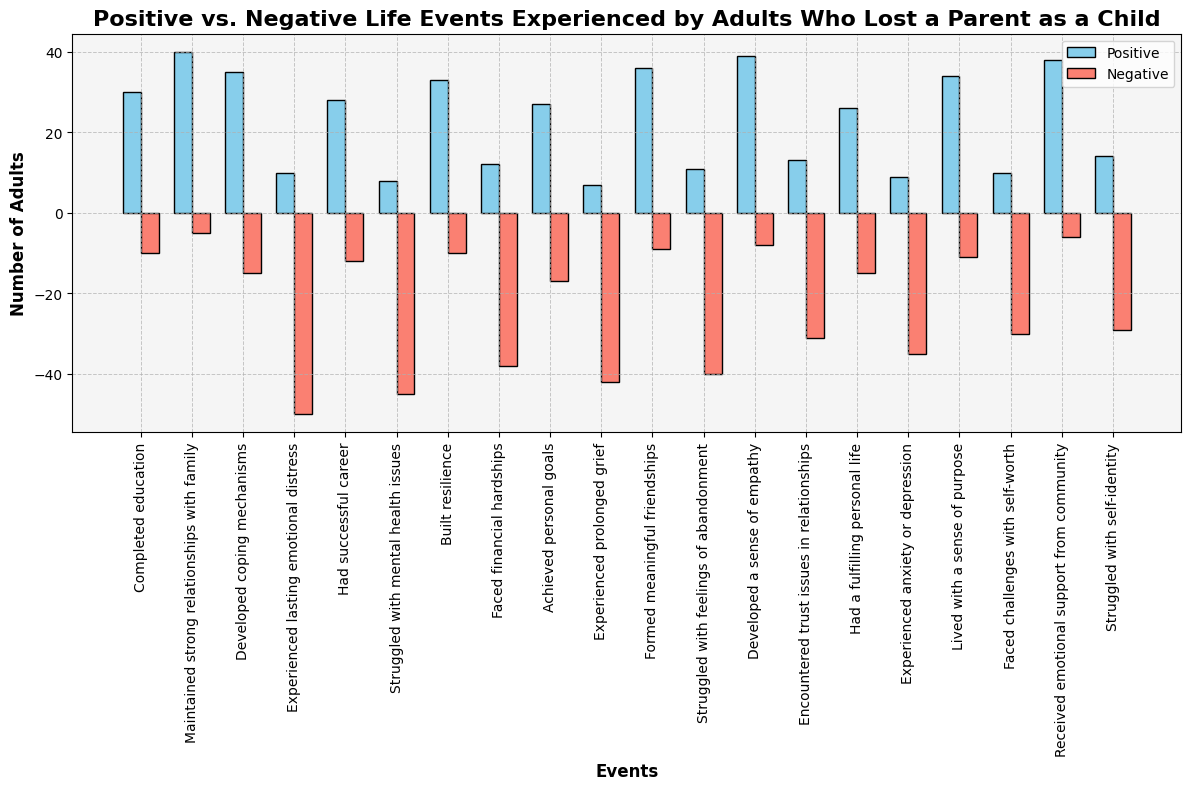What is the event with the highest number of adults experiencing positive life events? The tallest blue bar represents the highest number of adults experiencing positive life events. The highest bar is for the event "Maintained strong relationships with family."
Answer: Maintained strong relationships with family Which event has the largest difference between the number of adults experiencing positive and negative life events? To determine the largest difference, calculate the absolute difference between the positive and negative values for each event. The event "Experienced lasting emotional distress" has the largest difference with an absolute value difference of 60 (10 - (-50)).
Answer: Experienced lasting emotional distress Between "Faced financial hardships" and "Struggled with feelings of abandonment," which event has more adults experiencing negative life events? Compare the heights of the red bars for "Faced financial hardships" and "Struggled with feelings of abandonment." The bar for "Faced financial hardships" is taller, indicating more adults experiencing negative life events.
Answer: Faced financial hardships What is the total number of adults who had a successful career and lived with a sense of purpose in terms of positive life events? Sum the positive values of "Had successful career" (28) and "Lived with a sense of purpose" (34). The total number is 28 + 34 = 62.
Answer: 62 Which event has the closest number of adults experiencing both positive and negative life events? Evaluate the differences between the positive and negative values for each event. The event "Maintained strong relationships with family" has values of 40 for positive and -5 for negative, making the difference closest (absolute difference is 45).
Answer: Maintained strong relationships with family Identify the event with the lowest number of adults experiencing positive life events. The shortest blue bar signifies the lowest number of adults. The event "Experienced prolonged grief" has the shortest blue bar.
Answer: Experienced prolonged grief Are there more adults who developed coping mechanisms or adults who struggled with self-identity in terms of positive life events? Compare the blue bars for "Developed coping mechanisms" and "Struggled with self-identity." The blue bar for "Developed coping mechanisms" is taller, indicating more adults experienced positive life events.
Answer: Developed coping mechanisms Calculate the average number of adults experiencing negative life events for the events: "Encountered trust issues in relationships," "Faced challenges with self-worth," and "Struggled with self-identity." Sum the negative values for the three events: -31, -30, and -29. The total is -31 + -30 + -29 = -90. The average is -90 / 3 = -30.
Answer: -30 